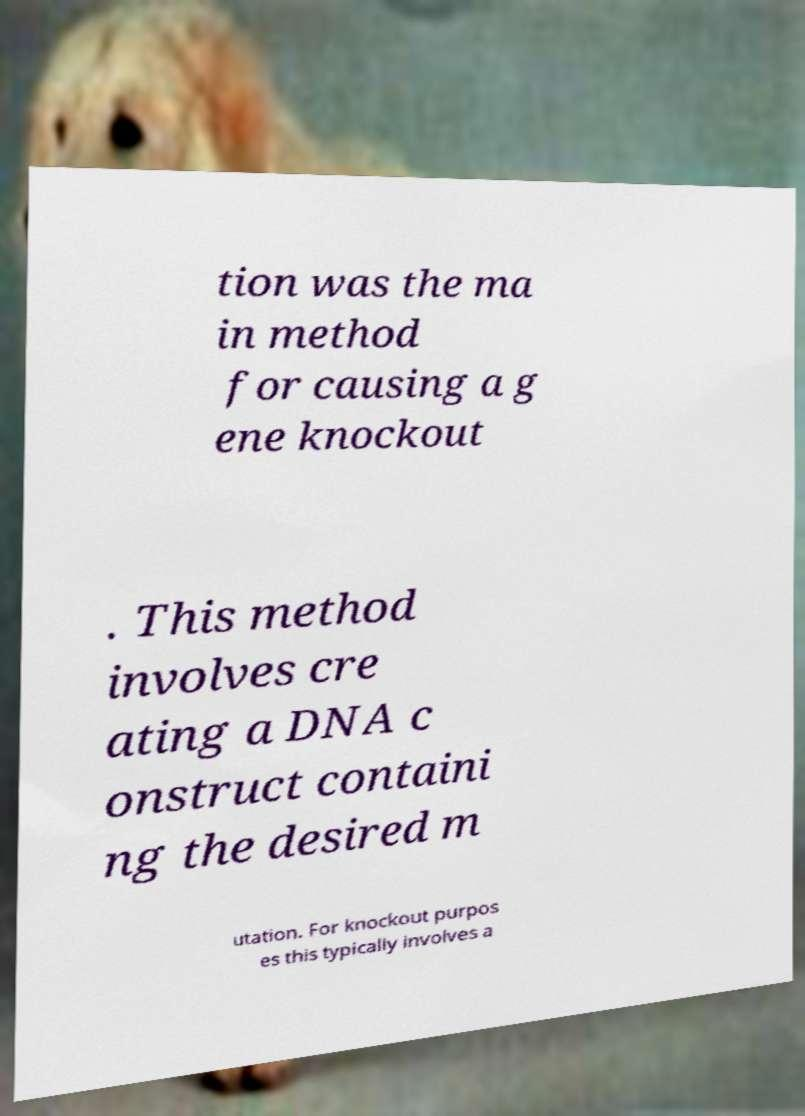Could you extract and type out the text from this image? tion was the ma in method for causing a g ene knockout . This method involves cre ating a DNA c onstruct containi ng the desired m utation. For knockout purpos es this typically involves a 